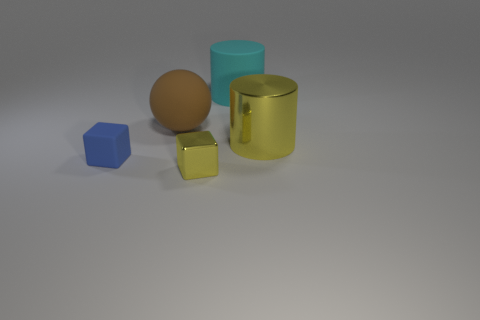There is a shiny cube that is the same color as the big metallic thing; what is its size?
Provide a succinct answer. Small. There is a brown object that is the same size as the yellow metallic cylinder; what is its shape?
Give a very brief answer. Sphere. What color is the cylinder that is the same material as the small blue block?
Give a very brief answer. Cyan. Is the shape of the large shiny object the same as the small thing that is to the left of the tiny yellow shiny block?
Provide a succinct answer. No. What material is the tiny cube that is the same color as the shiny cylinder?
Ensure brevity in your answer.  Metal. What material is the yellow object that is the same size as the blue thing?
Your answer should be very brief. Metal. Is there a small metallic thing of the same color as the sphere?
Offer a terse response. No. There is a thing that is on the right side of the tiny blue matte block and in front of the yellow cylinder; what is its shape?
Ensure brevity in your answer.  Cube. What number of tiny blue blocks are made of the same material as the sphere?
Your answer should be compact. 1. Are there fewer large balls right of the small yellow metallic thing than large cyan rubber cylinders on the left side of the big cyan matte cylinder?
Your answer should be compact. No. 